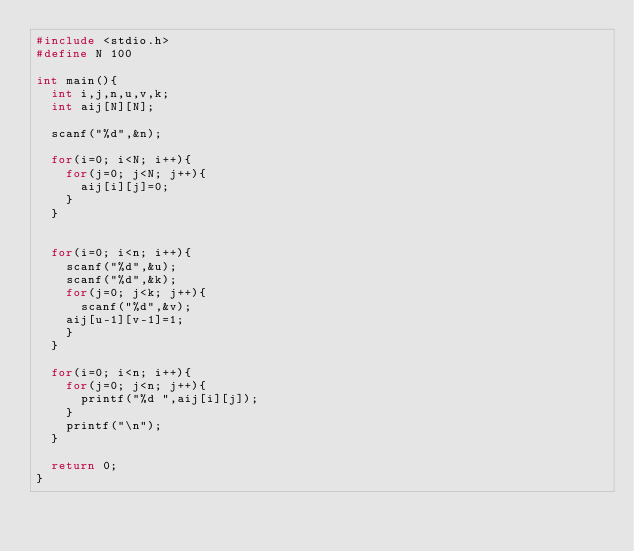<code> <loc_0><loc_0><loc_500><loc_500><_C_>#include <stdio.h>
#define N 100

int main(){
  int i,j,n,u,v,k;
  int aij[N][N];

  scanf("%d",&n);

  for(i=0; i<N; i++){
    for(j=0; j<N; j++){
      aij[i][j]=0;
    }
  }


  for(i=0; i<n; i++){
    scanf("%d",&u);
    scanf("%d",&k);
    for(j=0; j<k; j++){
      scanf("%d",&v);
	aij[u-1][v-1]=1;
    }
  }

  for(i=0; i<n; i++){
    for(j=0; j<n; j++){
      printf("%d ",aij[i][j]);
    }
    printf("\n");
  }

  return 0;
}</code> 